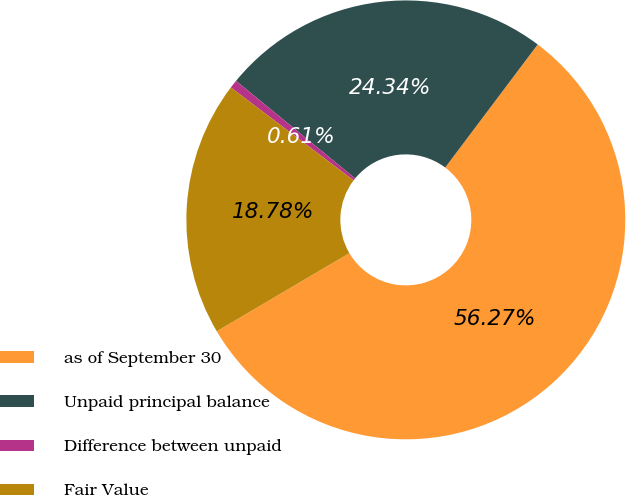<chart> <loc_0><loc_0><loc_500><loc_500><pie_chart><fcel>as of September 30<fcel>Unpaid principal balance<fcel>Difference between unpaid<fcel>Fair Value<nl><fcel>56.26%<fcel>24.34%<fcel>0.61%<fcel>18.78%<nl></chart> 